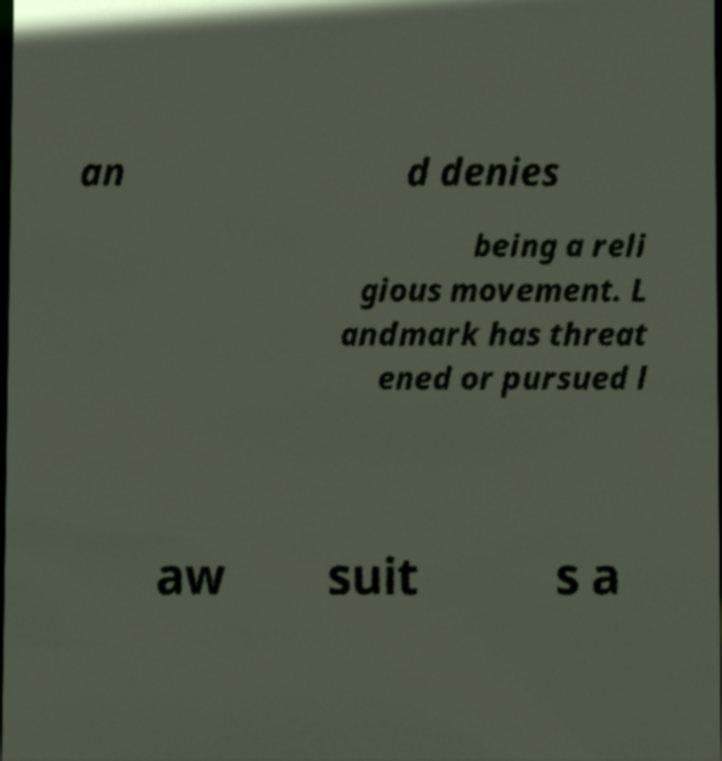Could you extract and type out the text from this image? an d denies being a reli gious movement. L andmark has threat ened or pursued l aw suit s a 